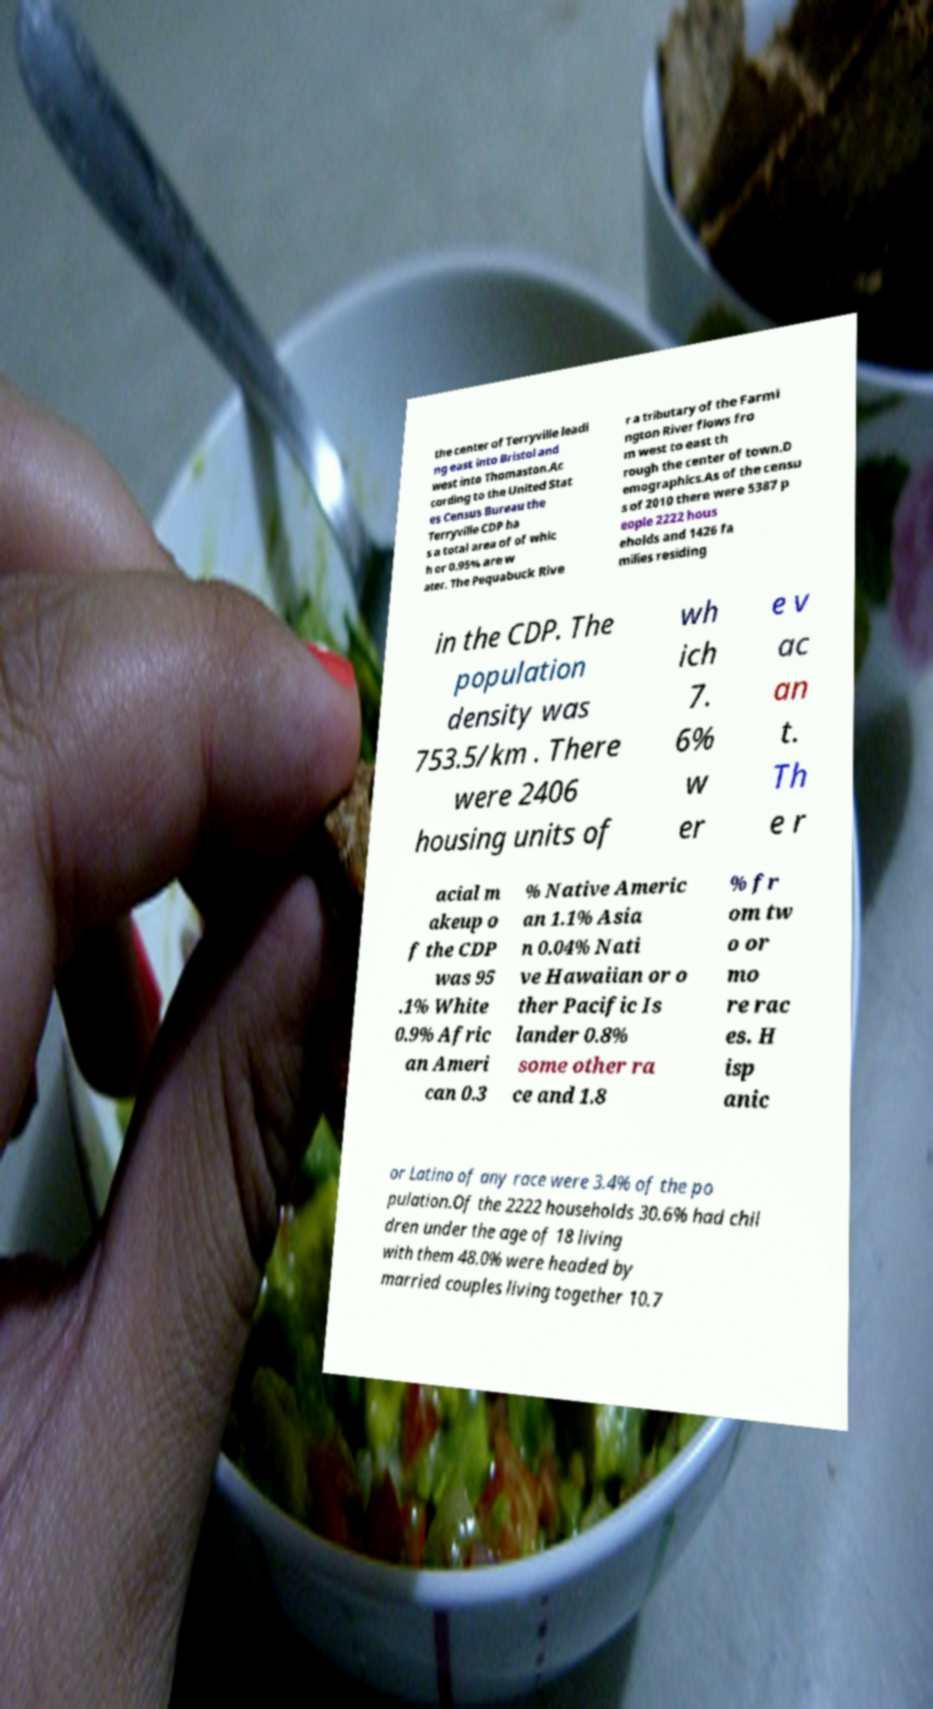There's text embedded in this image that I need extracted. Can you transcribe it verbatim? the center of Terryville leadi ng east into Bristol and west into Thomaston.Ac cording to the United Stat es Census Bureau the Terryville CDP ha s a total area of of whic h or 0.95% are w ater. The Pequabuck Rive r a tributary of the Farmi ngton River flows fro m west to east th rough the center of town.D emographics.As of the censu s of 2010 there were 5387 p eople 2222 hous eholds and 1426 fa milies residing in the CDP. The population density was 753.5/km . There were 2406 housing units of wh ich 7. 6% w er e v ac an t. Th e r acial m akeup o f the CDP was 95 .1% White 0.9% Afric an Ameri can 0.3 % Native Americ an 1.1% Asia n 0.04% Nati ve Hawaiian or o ther Pacific Is lander 0.8% some other ra ce and 1.8 % fr om tw o or mo re rac es. H isp anic or Latino of any race were 3.4% of the po pulation.Of the 2222 households 30.6% had chil dren under the age of 18 living with them 48.0% were headed by married couples living together 10.7 